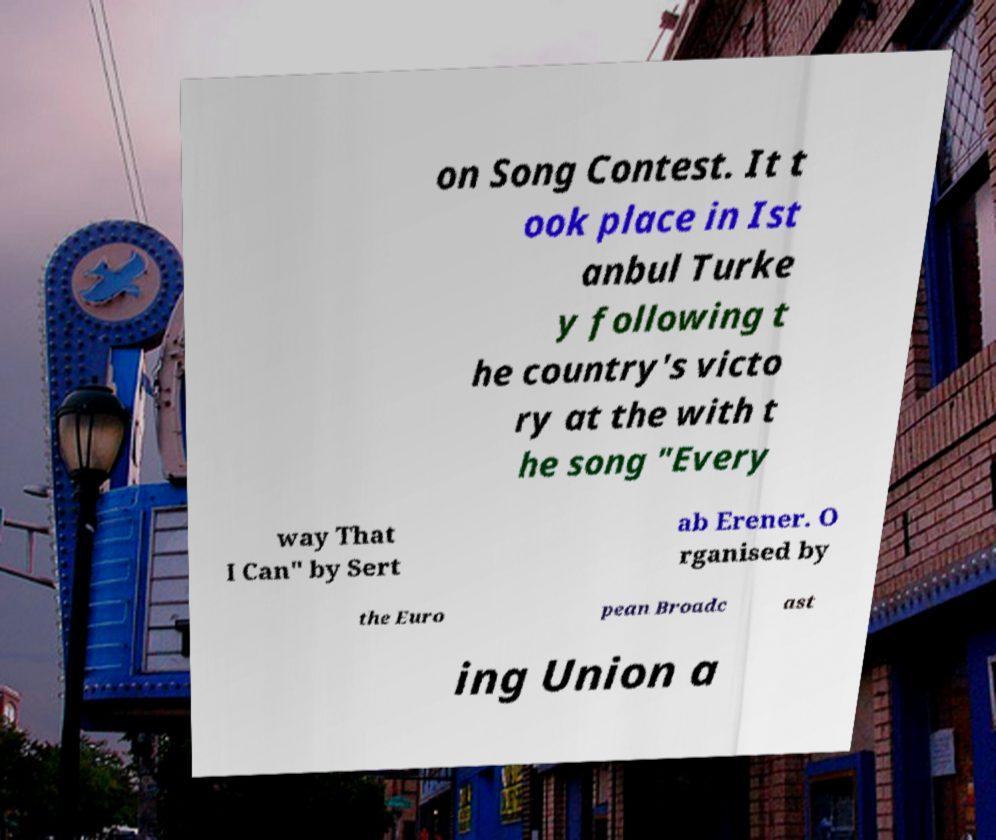What messages or text are displayed in this image? I need them in a readable, typed format. on Song Contest. It t ook place in Ist anbul Turke y following t he country's victo ry at the with t he song "Every way That I Can" by Sert ab Erener. O rganised by the Euro pean Broadc ast ing Union a 